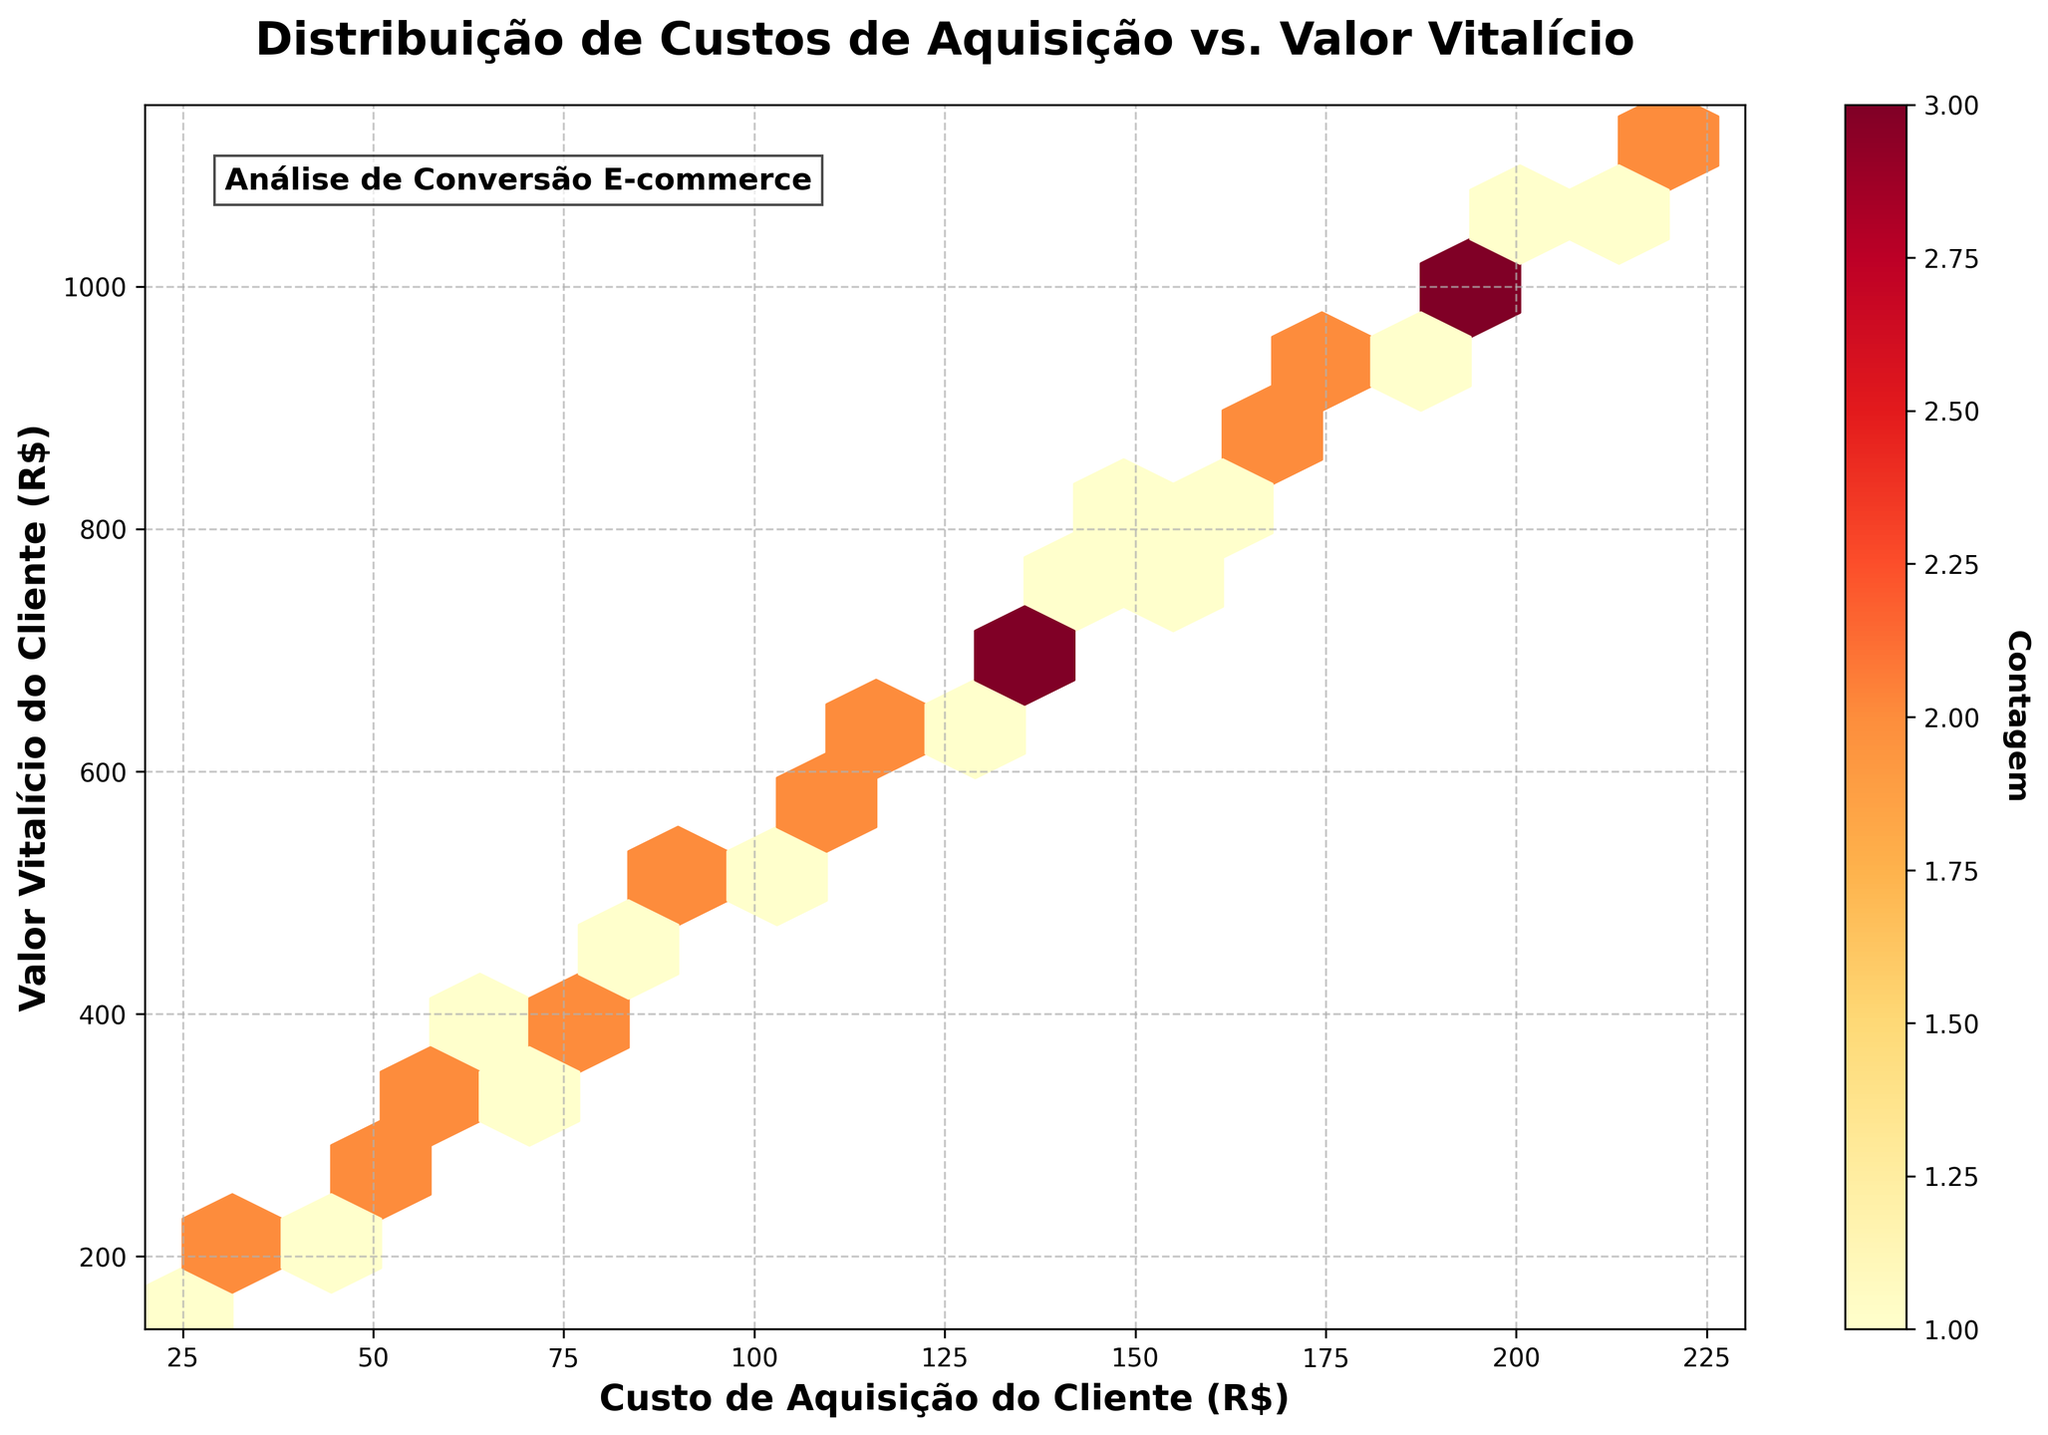What are the x and y-axis labels in the plot? The x-axis label is 'Custo de Aquisição do Cliente (R$)' and the y-axis label is 'Valor Vitalício do Cliente (R$)'. Read the labels directly from the axes of the plot.
Answer: Custo de Aquisição do Cliente (R$), Valor Vitalício do Cliente (R$) What does the color intensity represent in the hexbin plot? The color intensity in the hexbin plot represents the count of data points within each hexagon. This can be inferred from the color bar labeled 'Contagem' on the side of the plot.
Answer: The count of data points What is the title of the figure? The title of the figure is 'Distribuição de Custos de Aquisição vs. Valor Vitalício'. Read the title that is displayed at the top center of the plot.
Answer: Distribuição de Custos de Aquisição vs. Valor Vitalício What is the range of Customer Acquisition Cost values displayed on the x-axis? The x-axis ranges from 20 to 230 as shown by the x-axis limits in the plot.
Answer: 20 to 230 What is the highest Customer Lifetime Value shown on the y-axis? The y-axis shows values up to 1150, which is indicated by the y-axis limit.
Answer: 1150 What is the relationship pattern between Customer Acquisition Cost and Customer Lifetime Value? The relationship pattern appears to be linear; as the customer acquisition cost increases, the customer lifetime value also increases. This is inferred from the diagonal spread of hexagons from the bottom-left to top-right.
Answer: Linear Are there more data points at lower or higher acquisition costs? There are more data points at lower acquisition costs, which is indicated by the darker regions in the lower acquisition cost area of the plot.
Answer: Lower acquisition costs What is the approximate range of acquisition costs where the density of points is highest? The highest density of points appears to be in the range of approximately 50 to 150 for acquisition costs. This is indicated by the darkest hexagons in this range on the x-axis.
Answer: 50 to 150 Based on the plot, what acquisition cost range should you focus on for a better lifetime value? According to the plot, focusing on acquisition costs between 100 to 200 appears to yield higher lifetime values, as these ranges show a good balance between costs and higher lifetime values.
Answer: 100 to 200 Do higher acquisition costs always lead to higher lifetime values? Higher acquisition costs generally lead to higher lifetime values, but this is not always guaranteed as there are slight variations. This can be seen in the less dense, lighter-colored hexagons in higher acquisition cost regions still showing varying lifetime values.
Answer: Not always 